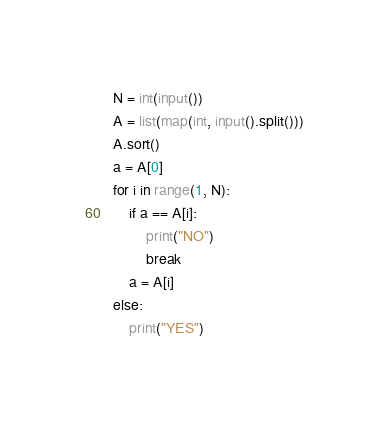Convert code to text. <code><loc_0><loc_0><loc_500><loc_500><_Python_>N = int(input())
A = list(map(int, input().split()))
A.sort()
a = A[0]
for i in range(1, N):
    if a == A[i]:
        print("NO")
        break
    a = A[i]
else:
    print("YES")
</code> 